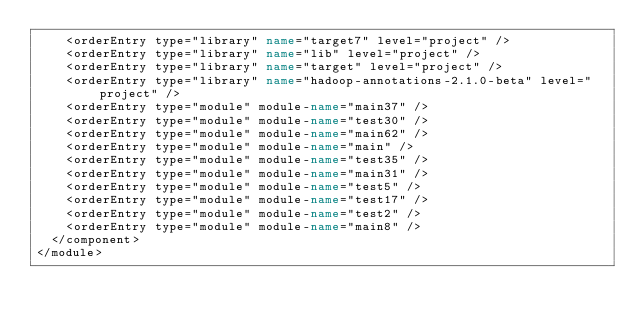Convert code to text. <code><loc_0><loc_0><loc_500><loc_500><_XML_>    <orderEntry type="library" name="target7" level="project" />
    <orderEntry type="library" name="lib" level="project" />
    <orderEntry type="library" name="target" level="project" />
    <orderEntry type="library" name="hadoop-annotations-2.1.0-beta" level="project" />
    <orderEntry type="module" module-name="main37" />
    <orderEntry type="module" module-name="test30" />
    <orderEntry type="module" module-name="main62" />
    <orderEntry type="module" module-name="main" />
    <orderEntry type="module" module-name="test35" />
    <orderEntry type="module" module-name="main31" />
    <orderEntry type="module" module-name="test5" />
    <orderEntry type="module" module-name="test17" />
    <orderEntry type="module" module-name="test2" />
    <orderEntry type="module" module-name="main8" />
  </component>
</module></code> 